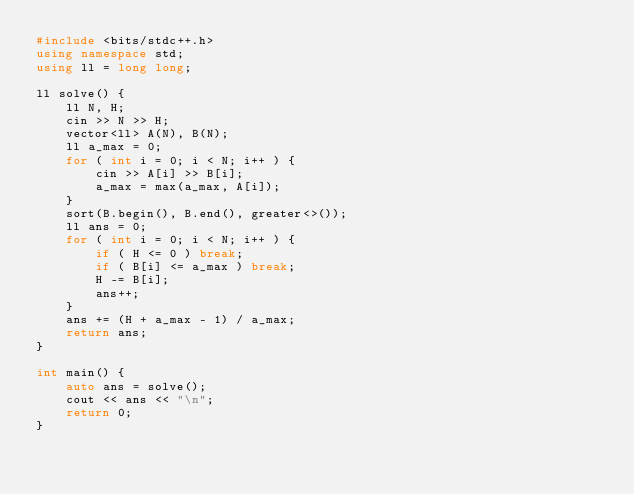<code> <loc_0><loc_0><loc_500><loc_500><_C++_>#include <bits/stdc++.h>
using namespace std;
using ll = long long;

ll solve() {
    ll N, H;
    cin >> N >> H;
    vector<ll> A(N), B(N);
    ll a_max = 0;
    for ( int i = 0; i < N; i++ ) {
        cin >> A[i] >> B[i];
        a_max = max(a_max, A[i]);
    }
    sort(B.begin(), B.end(), greater<>());
    ll ans = 0;
    for ( int i = 0; i < N; i++ ) {
        if ( H <= 0 ) break;
        if ( B[i] <= a_max ) break;
        H -= B[i];
        ans++;
    }
    ans += (H + a_max - 1) / a_max;
    return ans;
}

int main() {
    auto ans = solve();
    cout << ans << "\n";
    return 0;
}</code> 